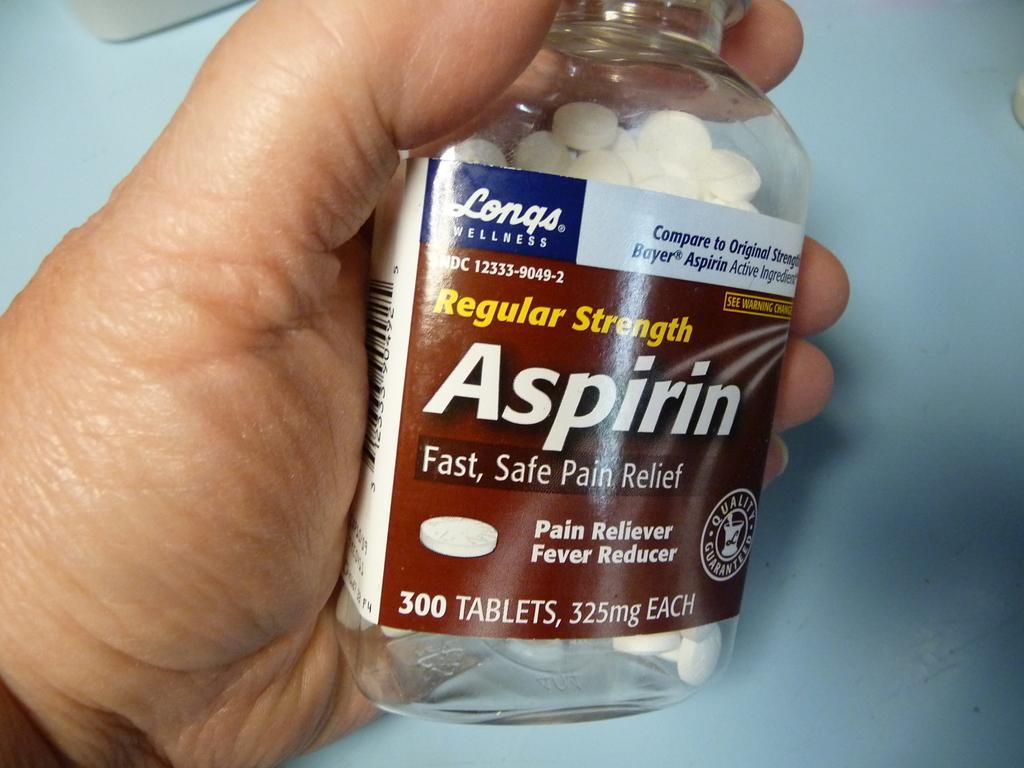In one or two sentences, can you explain what this image depicts? As we can see in the image there is a human hand holding bottle. 